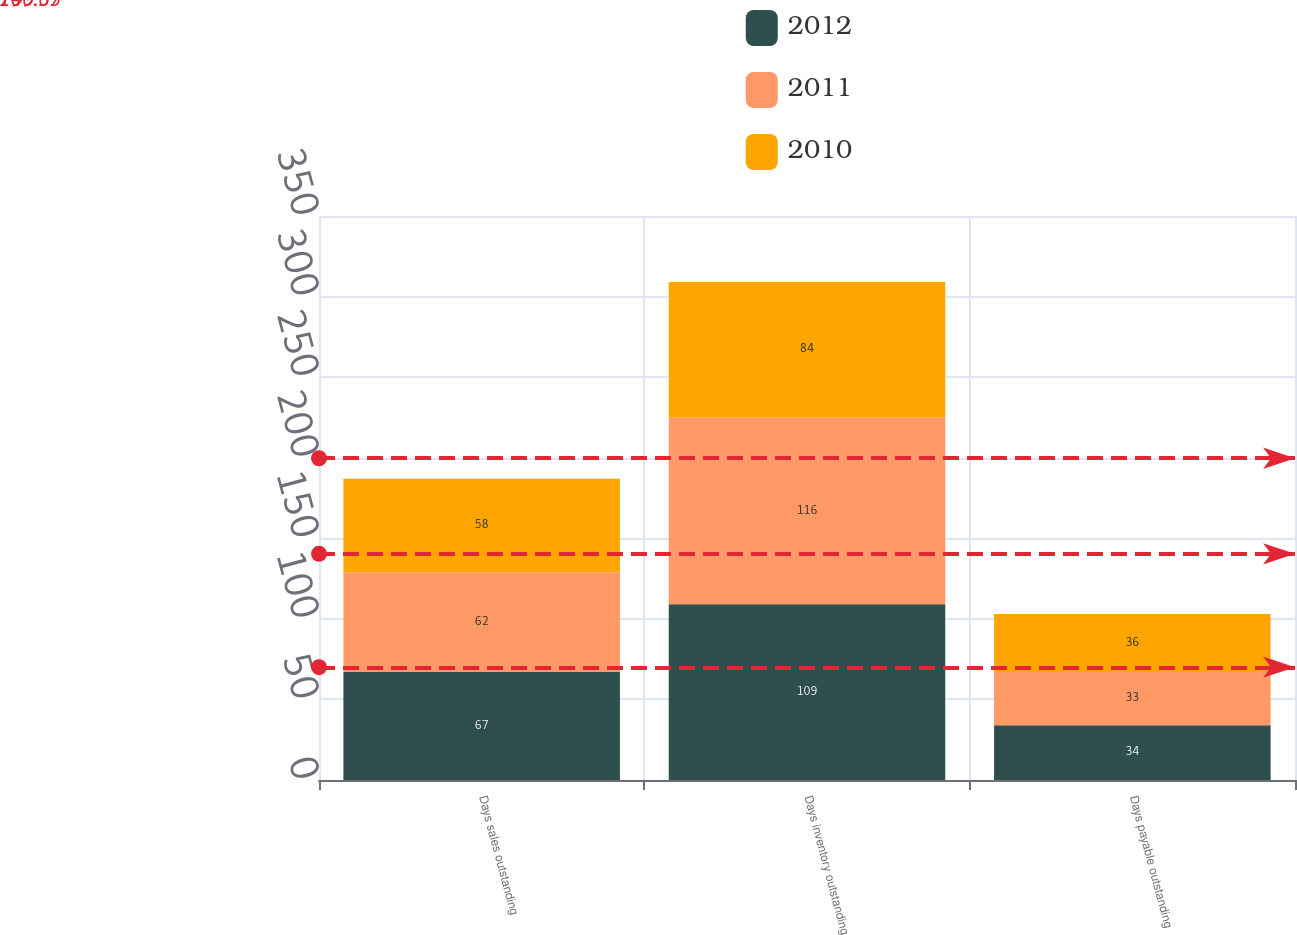Convert chart. <chart><loc_0><loc_0><loc_500><loc_500><stacked_bar_chart><ecel><fcel>Days sales outstanding<fcel>Days inventory outstanding<fcel>Days payable outstanding<nl><fcel>2012<fcel>67<fcel>109<fcel>34<nl><fcel>2011<fcel>62<fcel>116<fcel>33<nl><fcel>2010<fcel>58<fcel>84<fcel>36<nl></chart> 